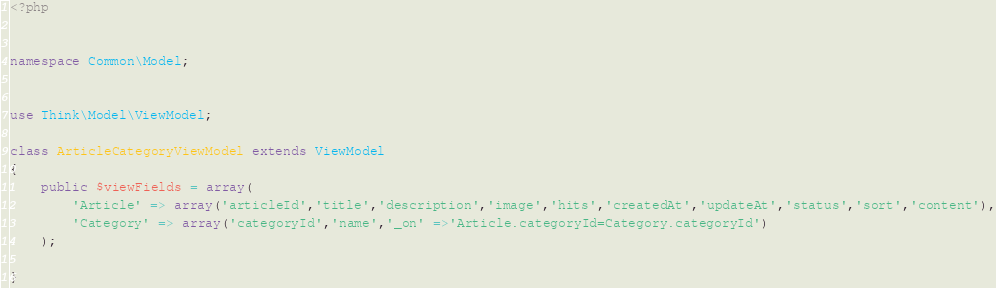<code> <loc_0><loc_0><loc_500><loc_500><_PHP_><?php


namespace Common\Model;


use Think\Model\ViewModel;

class ArticleCategoryViewModel extends ViewModel
{
    public $viewFields = array(
        'Article' => array('articleId','title','description','image','hits','createdAt','updateAt','status','sort','content'),
        'Category' => array('categoryId','name','_on' =>'Article.categoryId=Category.categoryId')
    );

}</code> 